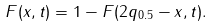Convert formula to latex. <formula><loc_0><loc_0><loc_500><loc_500>F ( x , t ) = 1 - F ( 2 q _ { 0 . 5 } - x , t ) .</formula> 